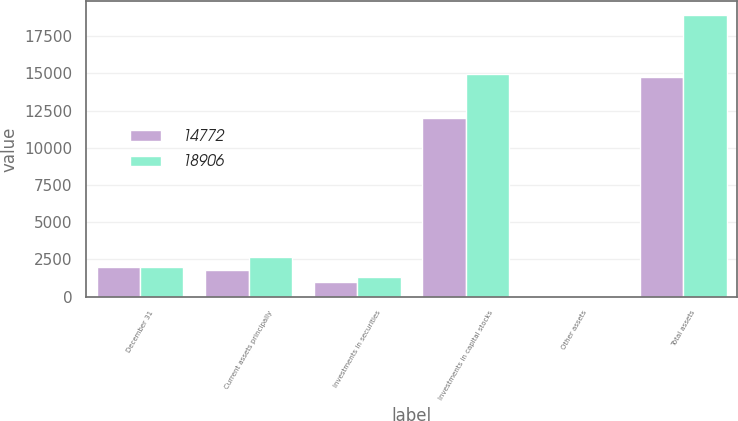Convert chart to OTSL. <chart><loc_0><loc_0><loc_500><loc_500><stacked_bar_chart><ecel><fcel>December 31<fcel>Current assets principally<fcel>Investments in securities<fcel>Investments in capital stocks<fcel>Other assets<fcel>Total assets<nl><fcel>14772<fcel>2008<fcel>1805<fcel>973<fcel>11973<fcel>21<fcel>14772<nl><fcel>18906<fcel>2007<fcel>2629<fcel>1290<fcel>14967<fcel>20<fcel>18906<nl></chart> 